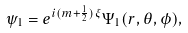Convert formula to latex. <formula><loc_0><loc_0><loc_500><loc_500>\psi _ { 1 } = e ^ { i ( m + \frac { 1 } { 2 } ) \xi } \Psi _ { 1 } ( r , \theta , \phi ) ,</formula> 